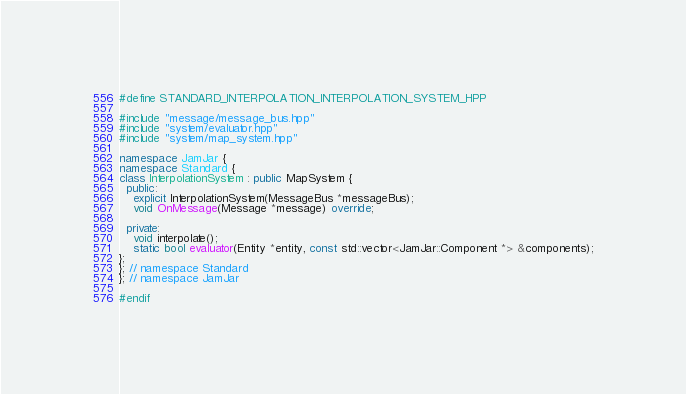Convert code to text. <code><loc_0><loc_0><loc_500><loc_500><_C++_>#define STANDARD_INTERPOLATION_INTERPOLATION_SYSTEM_HPP

#include "message/message_bus.hpp"
#include "system/evaluator.hpp"
#include "system/map_system.hpp"

namespace JamJar {
namespace Standard {
class InterpolationSystem : public MapSystem {
  public:
    explicit InterpolationSystem(MessageBus *messageBus);
    void OnMessage(Message *message) override;

  private:
    void interpolate();
    static bool evaluator(Entity *entity, const std::vector<JamJar::Component *> &components);
};
}; // namespace Standard
}; // namespace JamJar

#endif
</code> 